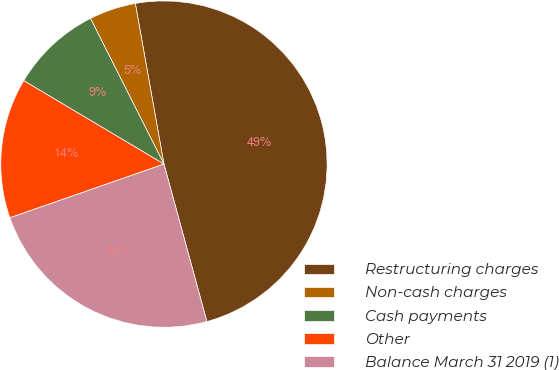Convert chart to OTSL. <chart><loc_0><loc_0><loc_500><loc_500><pie_chart><fcel>Restructuring charges<fcel>Non-cash charges<fcel>Cash payments<fcel>Other<fcel>Balance March 31 2019 (1)<nl><fcel>48.57%<fcel>4.63%<fcel>9.02%<fcel>13.88%<fcel>23.9%<nl></chart> 